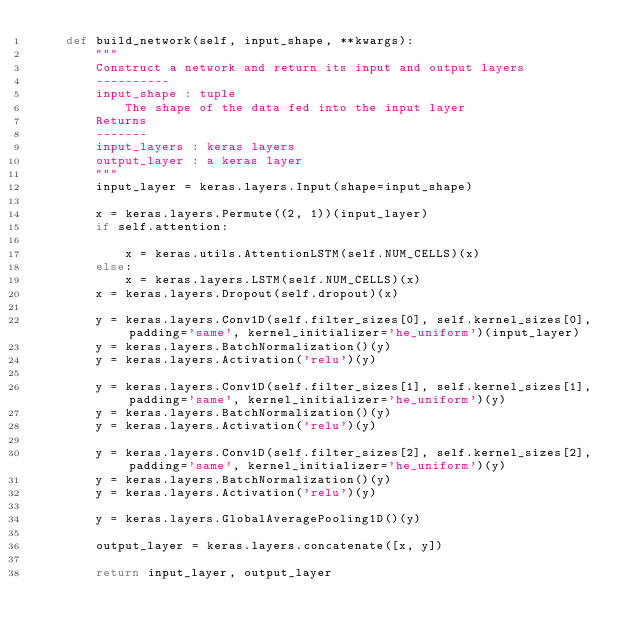<code> <loc_0><loc_0><loc_500><loc_500><_Python_>    def build_network(self, input_shape, **kwargs):
        """
        Construct a network and return its input and output layers
        ----------
        input_shape : tuple
            The shape of the data fed into the input layer
        Returns
        -------
        input_layers : keras layers
        output_layer : a keras layer
        """
        input_layer = keras.layers.Input(shape=input_shape)

        x = keras.layers.Permute((2, 1))(input_layer)
        if self.attention:

            x = keras.utils.AttentionLSTM(self.NUM_CELLS)(x)
        else:
            x = keras.layers.LSTM(self.NUM_CELLS)(x)
        x = keras.layers.Dropout(self.dropout)(x)

        y = keras.layers.Conv1D(self.filter_sizes[0], self.kernel_sizes[0], padding='same', kernel_initializer='he_uniform')(input_layer)
        y = keras.layers.BatchNormalization()(y)
        y = keras.layers.Activation('relu')(y)

        y = keras.layers.Conv1D(self.filter_sizes[1], self.kernel_sizes[1], padding='same', kernel_initializer='he_uniform')(y)
        y = keras.layers.BatchNormalization()(y)
        y = keras.layers.Activation('relu')(y)

        y = keras.layers.Conv1D(self.filter_sizes[2], self.kernel_sizes[2], padding='same', kernel_initializer='he_uniform')(y)
        y = keras.layers.BatchNormalization()(y)
        y = keras.layers.Activation('relu')(y)

        y = keras.layers.GlobalAveragePooling1D()(y)

        output_layer = keras.layers.concatenate([x, y])

        return input_layer, output_layer

</code> 